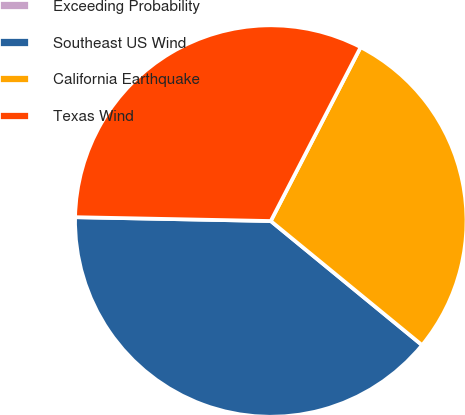<chart> <loc_0><loc_0><loc_500><loc_500><pie_chart><fcel>Exceeding Probability<fcel>Southeast US Wind<fcel>California Earthquake<fcel>Texas Wind<nl><fcel>0.0%<fcel>39.38%<fcel>28.34%<fcel>32.28%<nl></chart> 